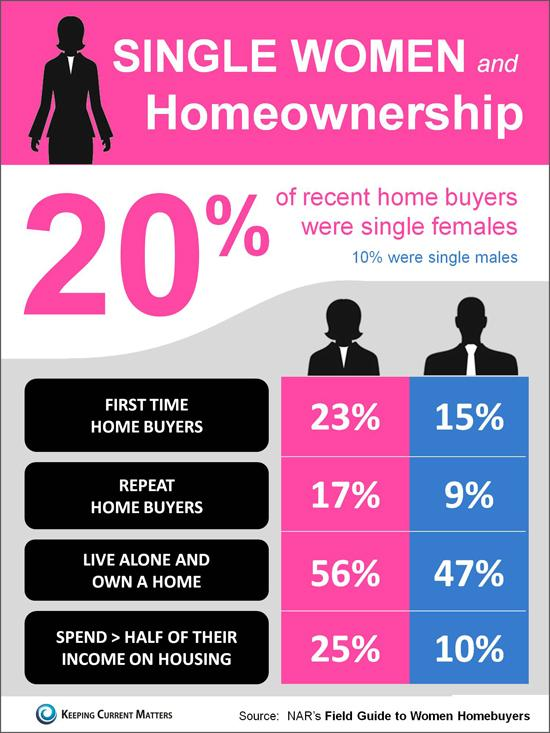Give some essential details in this illustration. The percentage by which single females are more likely to purchase a home than single males is 10%. Nine percent of male repeat home buyers were identified in the study. It is estimated that approximately 56% of females living alone own their own home. According to recent data, in the United States, approximately 25% of women spend more than half of their income on housing. 